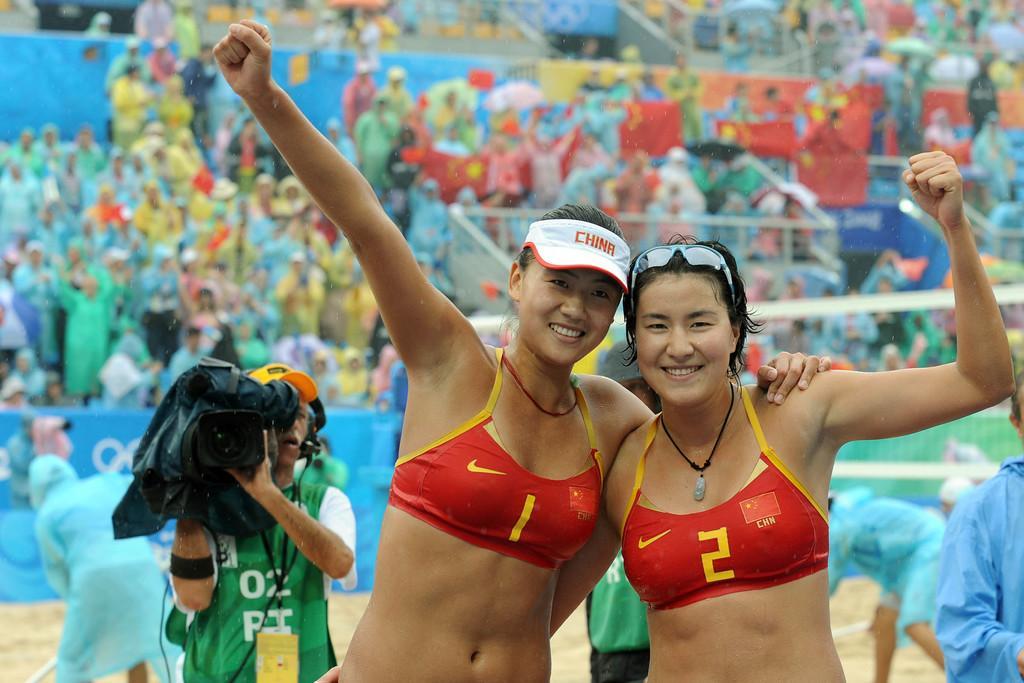Could you give a brief overview of what you see in this image? In this image there are two women posing for a photograph, in the background there are people standing a man holding camera. 